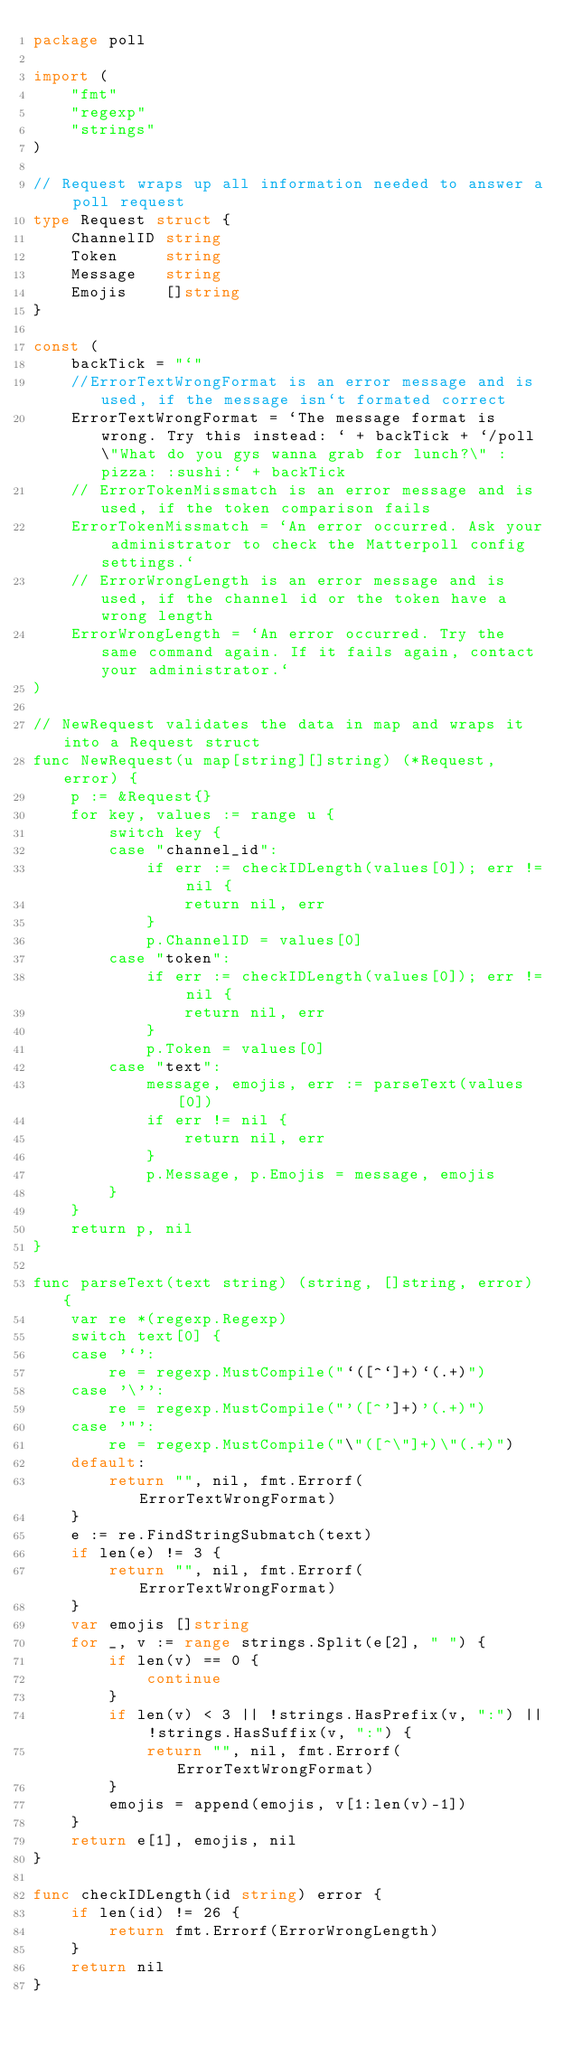<code> <loc_0><loc_0><loc_500><loc_500><_Go_>package poll

import (
	"fmt"
	"regexp"
	"strings"
)

// Request wraps up all information needed to answer a poll request
type Request struct {
	ChannelID string
	Token     string
	Message   string
	Emojis    []string
}

const (
	backTick = "`"
	//ErrorTextWrongFormat is an error message and is used, if the message isn`t formated correct
	ErrorTextWrongFormat = `The message format is wrong. Try this instead: ` + backTick + `/poll \"What do you gys wanna grab for lunch?\" :pizza: :sushi:` + backTick
	// ErrorTokenMissmatch is an error message and is used, if the token comparison fails
	ErrorTokenMissmatch = `An error occurred. Ask your administrator to check the Matterpoll config settings.`
	// ErrorWrongLength is an error message and is used, if the channel id or the token have a wrong length
	ErrorWrongLength = `An error occurred. Try the same command again. If it fails again, contact your administrator.`
)

// NewRequest validates the data in map and wraps it into a Request struct
func NewRequest(u map[string][]string) (*Request, error) {
	p := &Request{}
	for key, values := range u {
		switch key {
		case "channel_id":
			if err := checkIDLength(values[0]); err != nil {
				return nil, err
			}
			p.ChannelID = values[0]
		case "token":
			if err := checkIDLength(values[0]); err != nil {
				return nil, err
			}
			p.Token = values[0]
		case "text":
			message, emojis, err := parseText(values[0])
			if err != nil {
				return nil, err
			}
			p.Message, p.Emojis = message, emojis
		}
	}
	return p, nil
}

func parseText(text string) (string, []string, error) {
	var re *(regexp.Regexp)
	switch text[0] {
	case '`':
		re = regexp.MustCompile("`([^`]+)`(.+)")
	case '\'':
		re = regexp.MustCompile("'([^']+)'(.+)")
	case '"':
		re = regexp.MustCompile("\"([^\"]+)\"(.+)")
	default:
		return "", nil, fmt.Errorf(ErrorTextWrongFormat)
	}
	e := re.FindStringSubmatch(text)
	if len(e) != 3 {
		return "", nil, fmt.Errorf(ErrorTextWrongFormat)
	}
	var emojis []string
	for _, v := range strings.Split(e[2], " ") {
		if len(v) == 0 {
			continue
		}
		if len(v) < 3 || !strings.HasPrefix(v, ":") || !strings.HasSuffix(v, ":") {
			return "", nil, fmt.Errorf(ErrorTextWrongFormat)
		}
		emojis = append(emojis, v[1:len(v)-1])
	}
	return e[1], emojis, nil
}

func checkIDLength(id string) error {
	if len(id) != 26 {
		return fmt.Errorf(ErrorWrongLength)
	}
	return nil
}
</code> 